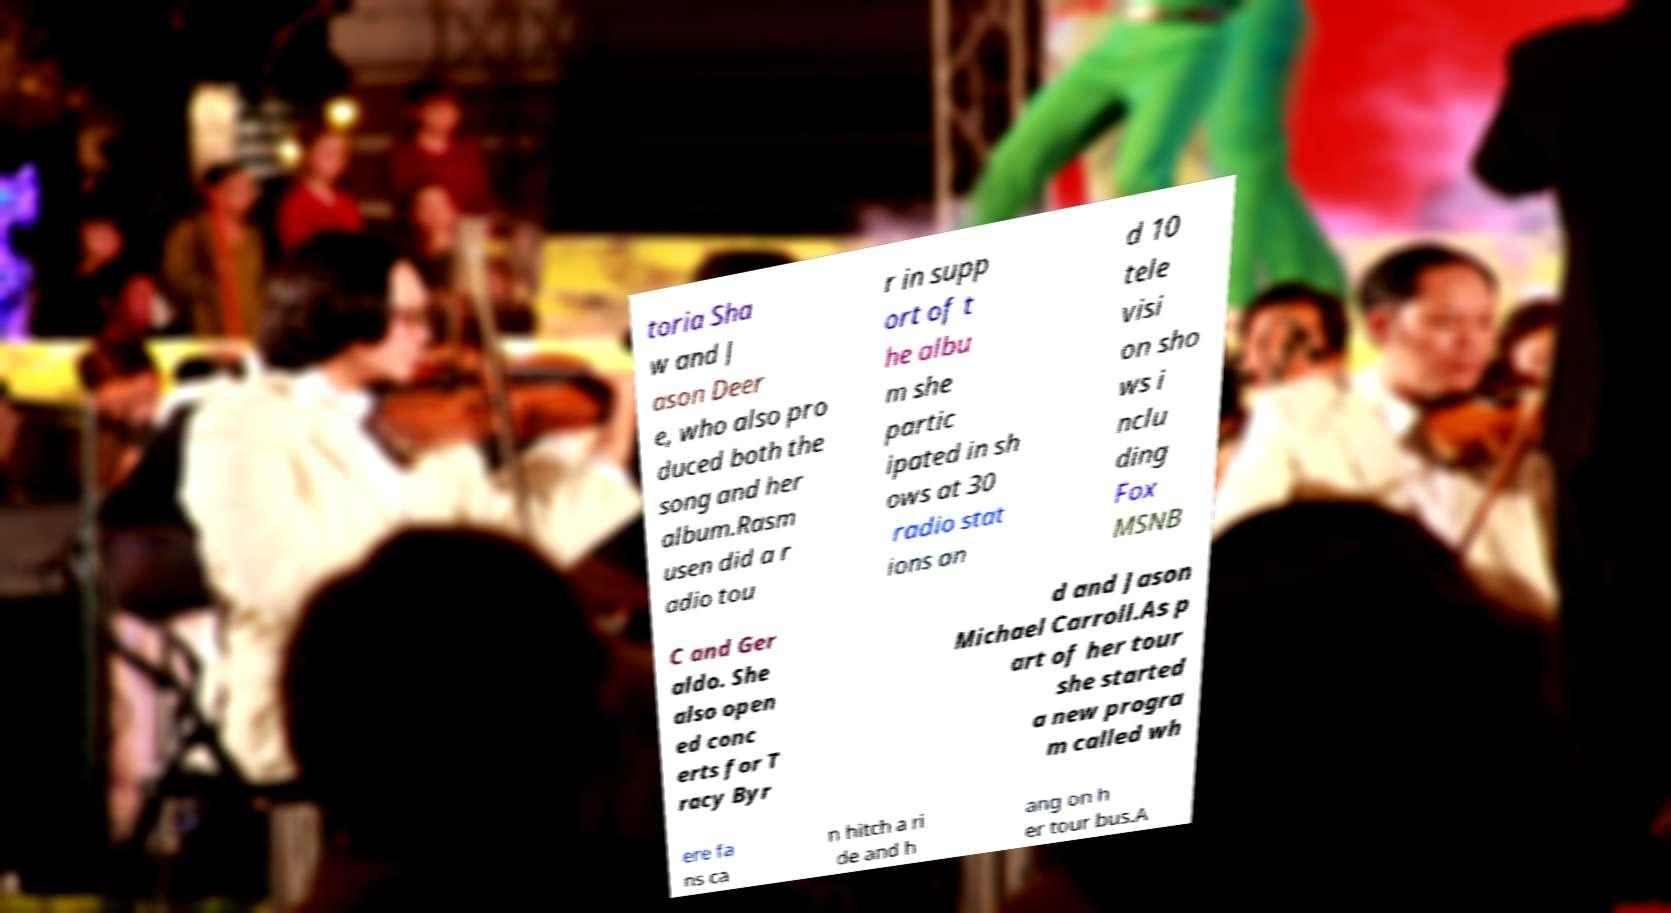There's text embedded in this image that I need extracted. Can you transcribe it verbatim? toria Sha w and J ason Deer e, who also pro duced both the song and her album.Rasm usen did a r adio tou r in supp ort of t he albu m she partic ipated in sh ows at 30 radio stat ions an d 10 tele visi on sho ws i nclu ding Fox MSNB C and Ger aldo. She also open ed conc erts for T racy Byr d and Jason Michael Carroll.As p art of her tour she started a new progra m called wh ere fa ns ca n hitch a ri de and h ang on h er tour bus.A 